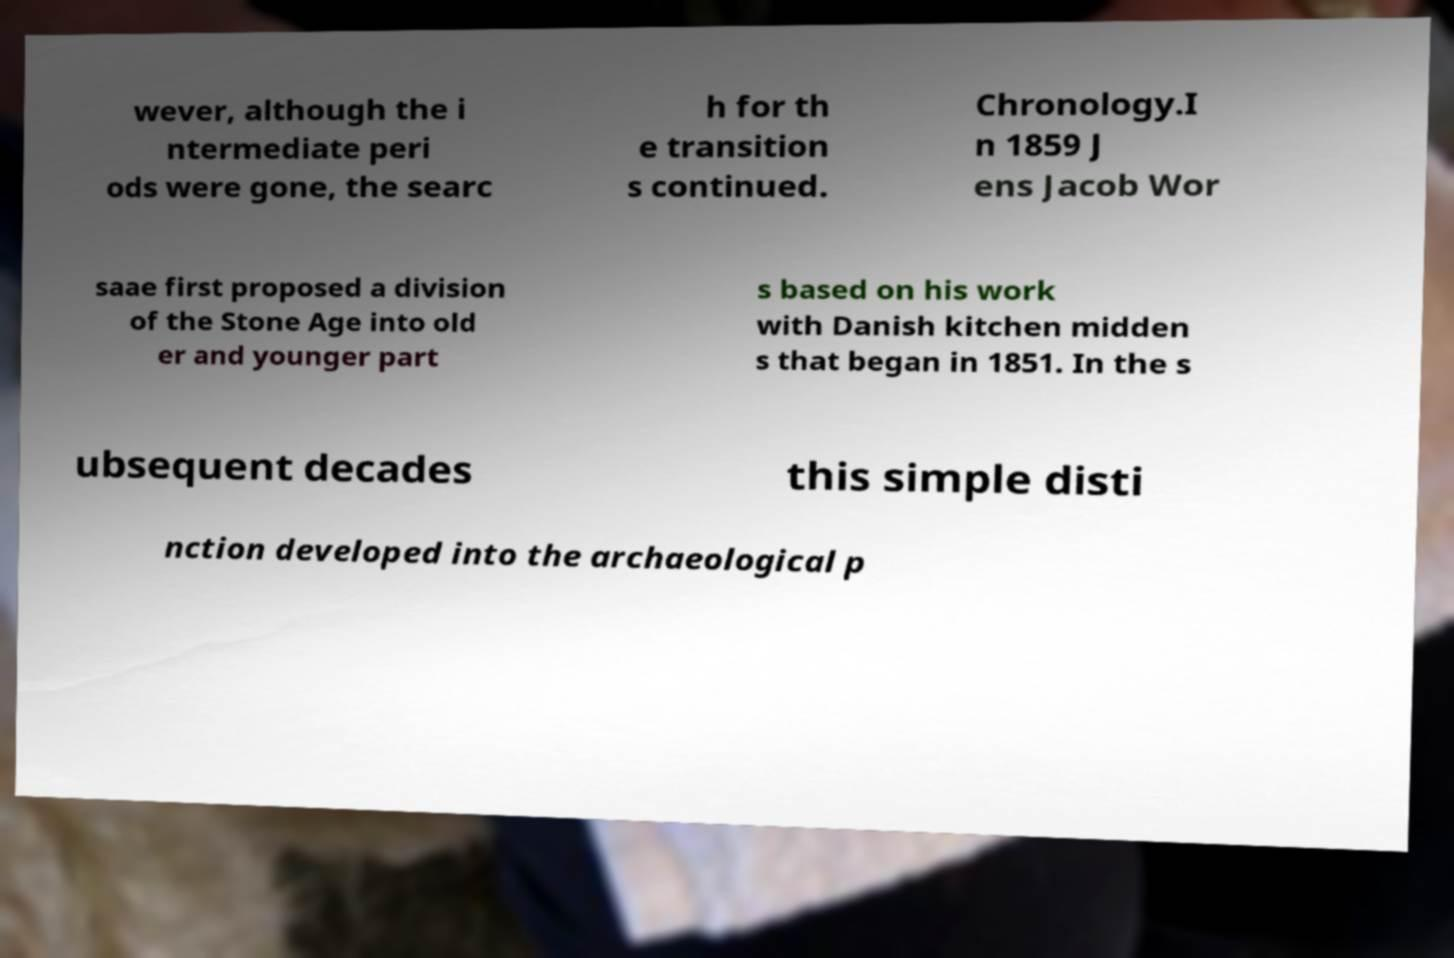Can you accurately transcribe the text from the provided image for me? wever, although the i ntermediate peri ods were gone, the searc h for th e transition s continued. Chronology.I n 1859 J ens Jacob Wor saae first proposed a division of the Stone Age into old er and younger part s based on his work with Danish kitchen midden s that began in 1851. In the s ubsequent decades this simple disti nction developed into the archaeological p 